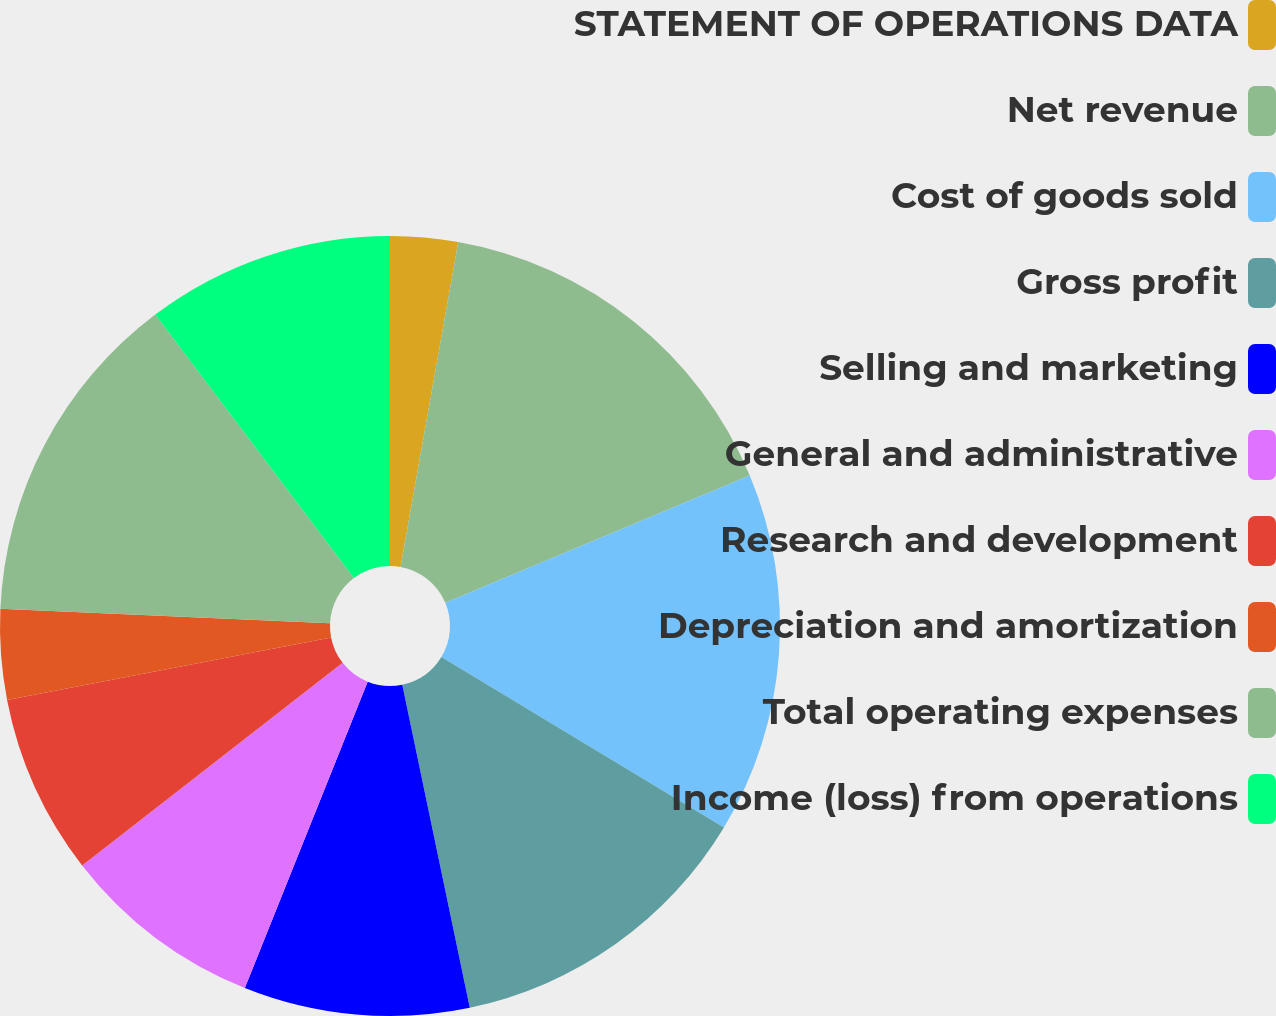<chart> <loc_0><loc_0><loc_500><loc_500><pie_chart><fcel>STATEMENT OF OPERATIONS DATA<fcel>Net revenue<fcel>Cost of goods sold<fcel>Gross profit<fcel>Selling and marketing<fcel>General and administrative<fcel>Research and development<fcel>Depreciation and amortization<fcel>Total operating expenses<fcel>Income (loss) from operations<nl><fcel>2.8%<fcel>15.89%<fcel>14.95%<fcel>13.08%<fcel>9.35%<fcel>8.41%<fcel>7.48%<fcel>3.74%<fcel>14.02%<fcel>10.28%<nl></chart> 